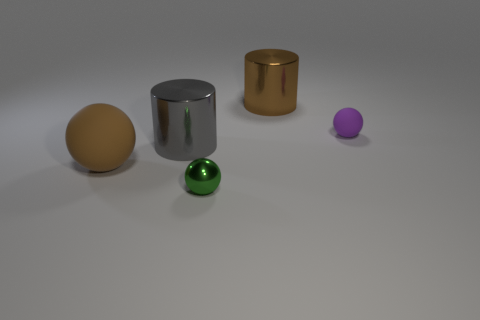How many tiny objects are either gray objects or shiny spheres?
Your response must be concise. 1. Does the brown thing that is left of the metallic ball have the same material as the purple ball on the right side of the big gray shiny thing?
Your answer should be very brief. Yes. What is the material of the big thing on the right side of the shiny ball?
Give a very brief answer. Metal. How many metallic objects are either small green balls or tiny purple spheres?
Your answer should be very brief. 1. There is a big cylinder that is right of the small green object that is to the left of the tiny purple matte ball; what color is it?
Provide a succinct answer. Brown. Does the big sphere have the same material as the cylinder right of the green metallic thing?
Provide a short and direct response. No. There is a thing that is in front of the brown object that is in front of the matte ball that is on the right side of the big brown shiny thing; what is its color?
Your answer should be very brief. Green. Is there any other thing that has the same shape as the small green object?
Provide a succinct answer. Yes. Are there more small blocks than brown matte objects?
Give a very brief answer. No. How many large objects are in front of the big brown cylinder and on the right side of the tiny shiny object?
Give a very brief answer. 0. 